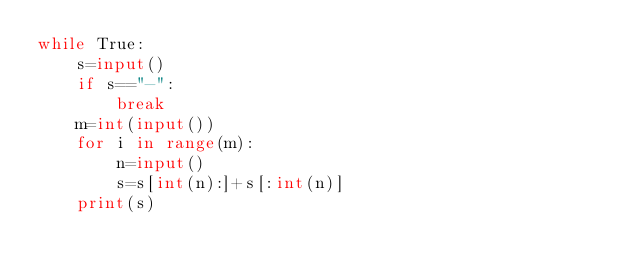Convert code to text. <code><loc_0><loc_0><loc_500><loc_500><_Python_>while True:
    s=input()
    if s=="-":
        break
    m=int(input())
    for i in range(m):
        n=input()
        s=s[int(n):]+s[:int(n)]
    print(s)</code> 